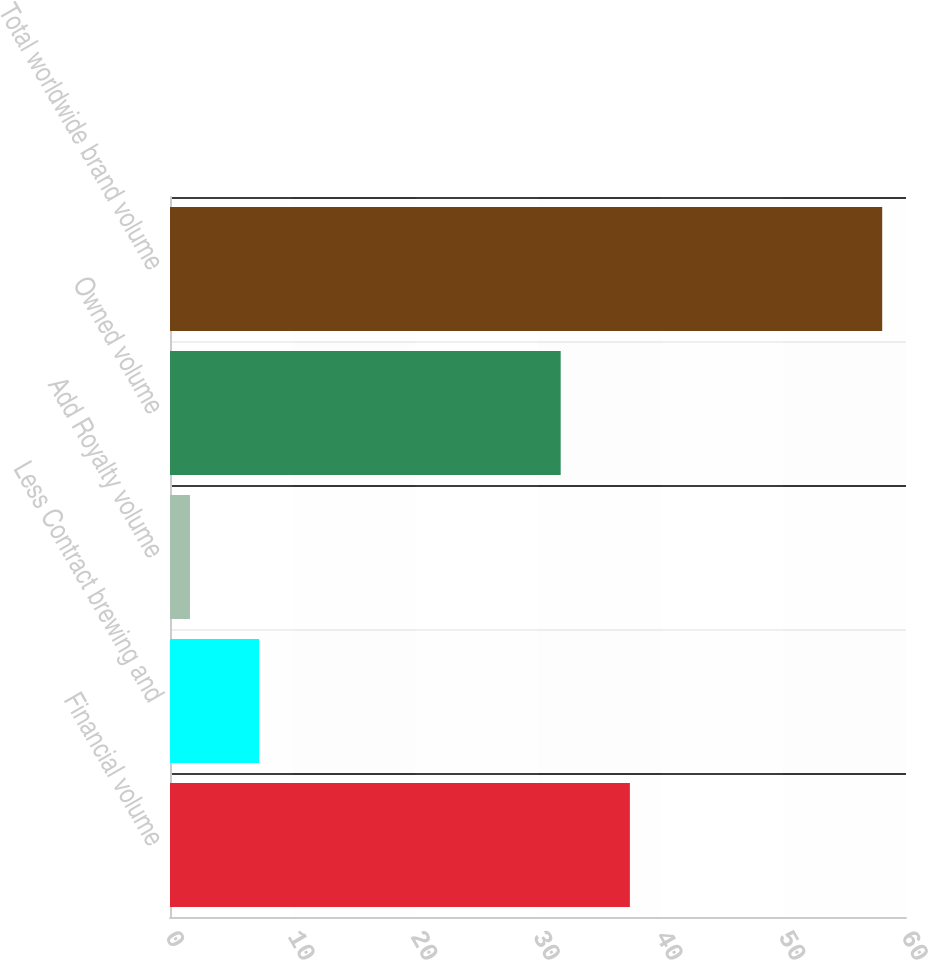Convert chart to OTSL. <chart><loc_0><loc_0><loc_500><loc_500><bar_chart><fcel>Financial volume<fcel>Less Contract brewing and<fcel>Add Royalty volume<fcel>Owned volume<fcel>Total worldwide brand volume<nl><fcel>37.49<fcel>7.27<fcel>1.63<fcel>31.85<fcel>58.06<nl></chart> 